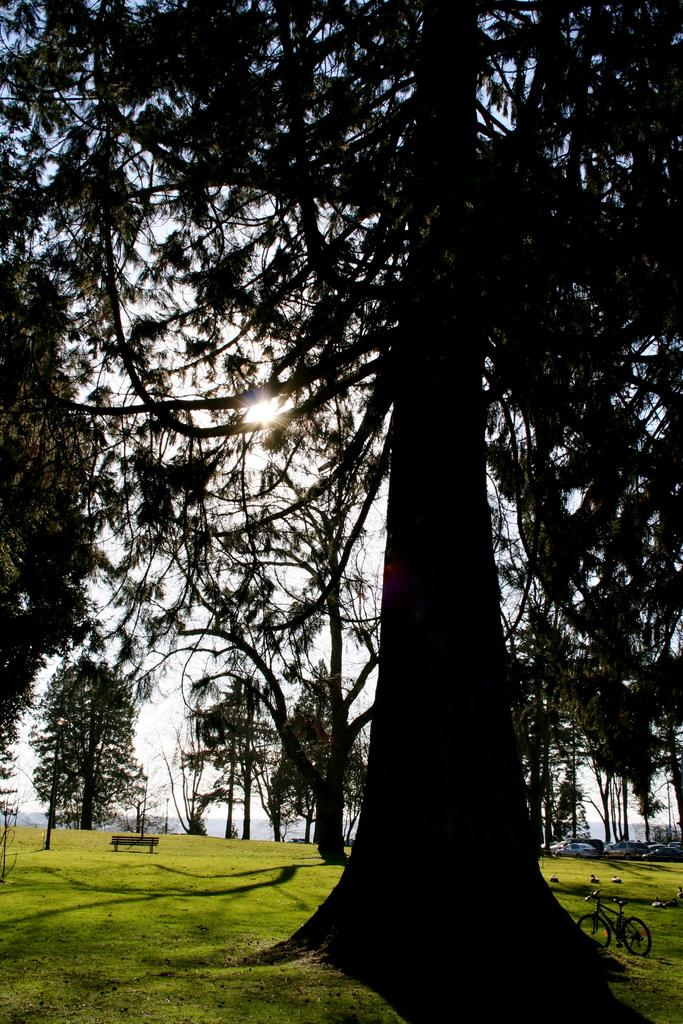What type of landscape is depicted in the image? There is a grassland in the image. What type of structure is present in the grassland? There is a bench in the grassland. What other object can be seen in the grassland? There is a bicycle in the grassland. What type of vegetation is visible in the image? There are trees in the image. Where can people find shade under a tree in the image? There is no specific tree mentioned in the image, so it is not possible to determine where people can find shade under a tree. 